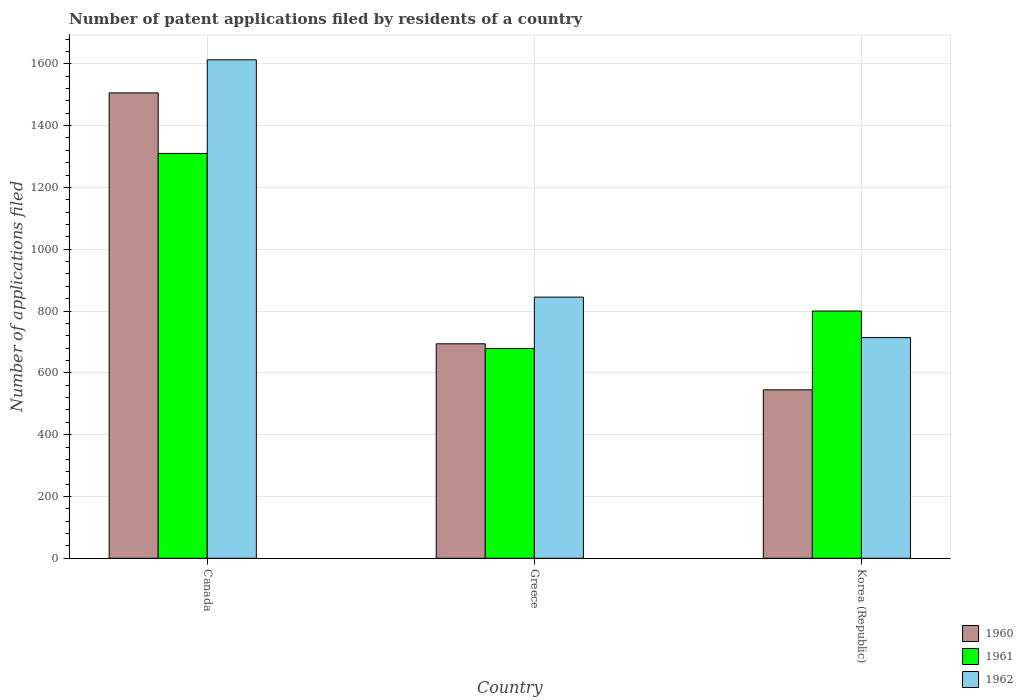How many different coloured bars are there?
Provide a succinct answer. 3. How many bars are there on the 3rd tick from the left?
Ensure brevity in your answer.  3. What is the label of the 3rd group of bars from the left?
Offer a terse response. Korea (Republic). What is the number of applications filed in 1960 in Greece?
Provide a succinct answer. 694. Across all countries, what is the maximum number of applications filed in 1960?
Offer a terse response. 1506. Across all countries, what is the minimum number of applications filed in 1960?
Provide a succinct answer. 545. In which country was the number of applications filed in 1962 maximum?
Your answer should be very brief. Canada. In which country was the number of applications filed in 1960 minimum?
Your response must be concise. Korea (Republic). What is the total number of applications filed in 1961 in the graph?
Give a very brief answer. 2789. What is the difference between the number of applications filed in 1962 in Canada and that in Greece?
Give a very brief answer. 768. What is the difference between the number of applications filed in 1960 in Greece and the number of applications filed in 1962 in Korea (Republic)?
Make the answer very short. -20. What is the average number of applications filed in 1960 per country?
Provide a short and direct response. 915. What is the difference between the number of applications filed of/in 1960 and number of applications filed of/in 1962 in Canada?
Your answer should be very brief. -107. What is the ratio of the number of applications filed in 1961 in Greece to that in Korea (Republic)?
Ensure brevity in your answer.  0.85. Is the difference between the number of applications filed in 1960 in Canada and Greece greater than the difference between the number of applications filed in 1962 in Canada and Greece?
Offer a terse response. Yes. What is the difference between the highest and the second highest number of applications filed in 1961?
Offer a very short reply. -510. What is the difference between the highest and the lowest number of applications filed in 1960?
Your response must be concise. 961. In how many countries, is the number of applications filed in 1961 greater than the average number of applications filed in 1961 taken over all countries?
Give a very brief answer. 1. Is it the case that in every country, the sum of the number of applications filed in 1961 and number of applications filed in 1960 is greater than the number of applications filed in 1962?
Keep it short and to the point. Yes. What is the difference between two consecutive major ticks on the Y-axis?
Your answer should be very brief. 200. How many legend labels are there?
Keep it short and to the point. 3. How are the legend labels stacked?
Provide a short and direct response. Vertical. What is the title of the graph?
Your answer should be very brief. Number of patent applications filed by residents of a country. Does "1995" appear as one of the legend labels in the graph?
Provide a succinct answer. No. What is the label or title of the X-axis?
Offer a very short reply. Country. What is the label or title of the Y-axis?
Offer a terse response. Number of applications filed. What is the Number of applications filed in 1960 in Canada?
Your answer should be very brief. 1506. What is the Number of applications filed in 1961 in Canada?
Make the answer very short. 1310. What is the Number of applications filed of 1962 in Canada?
Your answer should be very brief. 1613. What is the Number of applications filed of 1960 in Greece?
Ensure brevity in your answer.  694. What is the Number of applications filed in 1961 in Greece?
Offer a very short reply. 679. What is the Number of applications filed of 1962 in Greece?
Your answer should be very brief. 845. What is the Number of applications filed in 1960 in Korea (Republic)?
Keep it short and to the point. 545. What is the Number of applications filed in 1961 in Korea (Republic)?
Provide a succinct answer. 800. What is the Number of applications filed of 1962 in Korea (Republic)?
Your response must be concise. 714. Across all countries, what is the maximum Number of applications filed of 1960?
Offer a very short reply. 1506. Across all countries, what is the maximum Number of applications filed in 1961?
Your answer should be very brief. 1310. Across all countries, what is the maximum Number of applications filed in 1962?
Offer a terse response. 1613. Across all countries, what is the minimum Number of applications filed in 1960?
Keep it short and to the point. 545. Across all countries, what is the minimum Number of applications filed of 1961?
Provide a succinct answer. 679. Across all countries, what is the minimum Number of applications filed in 1962?
Ensure brevity in your answer.  714. What is the total Number of applications filed in 1960 in the graph?
Keep it short and to the point. 2745. What is the total Number of applications filed in 1961 in the graph?
Provide a short and direct response. 2789. What is the total Number of applications filed of 1962 in the graph?
Ensure brevity in your answer.  3172. What is the difference between the Number of applications filed in 1960 in Canada and that in Greece?
Offer a terse response. 812. What is the difference between the Number of applications filed of 1961 in Canada and that in Greece?
Ensure brevity in your answer.  631. What is the difference between the Number of applications filed in 1962 in Canada and that in Greece?
Your answer should be compact. 768. What is the difference between the Number of applications filed of 1960 in Canada and that in Korea (Republic)?
Provide a succinct answer. 961. What is the difference between the Number of applications filed of 1961 in Canada and that in Korea (Republic)?
Keep it short and to the point. 510. What is the difference between the Number of applications filed of 1962 in Canada and that in Korea (Republic)?
Provide a succinct answer. 899. What is the difference between the Number of applications filed in 1960 in Greece and that in Korea (Republic)?
Your answer should be very brief. 149. What is the difference between the Number of applications filed of 1961 in Greece and that in Korea (Republic)?
Keep it short and to the point. -121. What is the difference between the Number of applications filed in 1962 in Greece and that in Korea (Republic)?
Your answer should be compact. 131. What is the difference between the Number of applications filed in 1960 in Canada and the Number of applications filed in 1961 in Greece?
Provide a succinct answer. 827. What is the difference between the Number of applications filed of 1960 in Canada and the Number of applications filed of 1962 in Greece?
Your answer should be compact. 661. What is the difference between the Number of applications filed of 1961 in Canada and the Number of applications filed of 1962 in Greece?
Offer a terse response. 465. What is the difference between the Number of applications filed of 1960 in Canada and the Number of applications filed of 1961 in Korea (Republic)?
Your answer should be compact. 706. What is the difference between the Number of applications filed of 1960 in Canada and the Number of applications filed of 1962 in Korea (Republic)?
Give a very brief answer. 792. What is the difference between the Number of applications filed of 1961 in Canada and the Number of applications filed of 1962 in Korea (Republic)?
Your answer should be very brief. 596. What is the difference between the Number of applications filed in 1960 in Greece and the Number of applications filed in 1961 in Korea (Republic)?
Provide a succinct answer. -106. What is the difference between the Number of applications filed of 1960 in Greece and the Number of applications filed of 1962 in Korea (Republic)?
Keep it short and to the point. -20. What is the difference between the Number of applications filed of 1961 in Greece and the Number of applications filed of 1962 in Korea (Republic)?
Your answer should be very brief. -35. What is the average Number of applications filed of 1960 per country?
Your answer should be compact. 915. What is the average Number of applications filed of 1961 per country?
Ensure brevity in your answer.  929.67. What is the average Number of applications filed of 1962 per country?
Keep it short and to the point. 1057.33. What is the difference between the Number of applications filed of 1960 and Number of applications filed of 1961 in Canada?
Your answer should be very brief. 196. What is the difference between the Number of applications filed in 1960 and Number of applications filed in 1962 in Canada?
Provide a succinct answer. -107. What is the difference between the Number of applications filed of 1961 and Number of applications filed of 1962 in Canada?
Give a very brief answer. -303. What is the difference between the Number of applications filed of 1960 and Number of applications filed of 1962 in Greece?
Provide a succinct answer. -151. What is the difference between the Number of applications filed of 1961 and Number of applications filed of 1962 in Greece?
Provide a succinct answer. -166. What is the difference between the Number of applications filed in 1960 and Number of applications filed in 1961 in Korea (Republic)?
Your answer should be compact. -255. What is the difference between the Number of applications filed of 1960 and Number of applications filed of 1962 in Korea (Republic)?
Keep it short and to the point. -169. What is the difference between the Number of applications filed in 1961 and Number of applications filed in 1962 in Korea (Republic)?
Provide a short and direct response. 86. What is the ratio of the Number of applications filed of 1960 in Canada to that in Greece?
Give a very brief answer. 2.17. What is the ratio of the Number of applications filed of 1961 in Canada to that in Greece?
Keep it short and to the point. 1.93. What is the ratio of the Number of applications filed of 1962 in Canada to that in Greece?
Offer a very short reply. 1.91. What is the ratio of the Number of applications filed in 1960 in Canada to that in Korea (Republic)?
Ensure brevity in your answer.  2.76. What is the ratio of the Number of applications filed in 1961 in Canada to that in Korea (Republic)?
Keep it short and to the point. 1.64. What is the ratio of the Number of applications filed of 1962 in Canada to that in Korea (Republic)?
Provide a succinct answer. 2.26. What is the ratio of the Number of applications filed of 1960 in Greece to that in Korea (Republic)?
Offer a terse response. 1.27. What is the ratio of the Number of applications filed in 1961 in Greece to that in Korea (Republic)?
Ensure brevity in your answer.  0.85. What is the ratio of the Number of applications filed of 1962 in Greece to that in Korea (Republic)?
Your response must be concise. 1.18. What is the difference between the highest and the second highest Number of applications filed of 1960?
Keep it short and to the point. 812. What is the difference between the highest and the second highest Number of applications filed of 1961?
Offer a very short reply. 510. What is the difference between the highest and the second highest Number of applications filed of 1962?
Offer a very short reply. 768. What is the difference between the highest and the lowest Number of applications filed of 1960?
Your response must be concise. 961. What is the difference between the highest and the lowest Number of applications filed in 1961?
Keep it short and to the point. 631. What is the difference between the highest and the lowest Number of applications filed in 1962?
Provide a short and direct response. 899. 